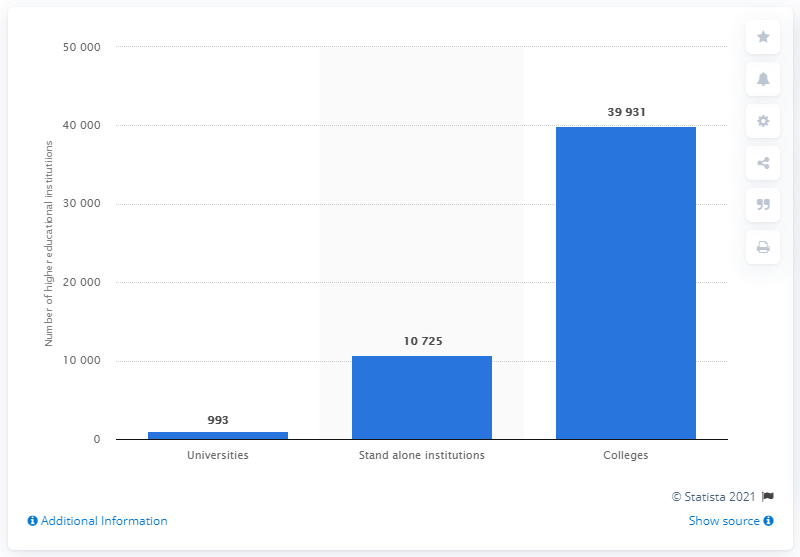Give some essential details in this illustration. In 2019, a total of 993 universities were listed on the AISHE (All India Survey on Higher Education) portal. 